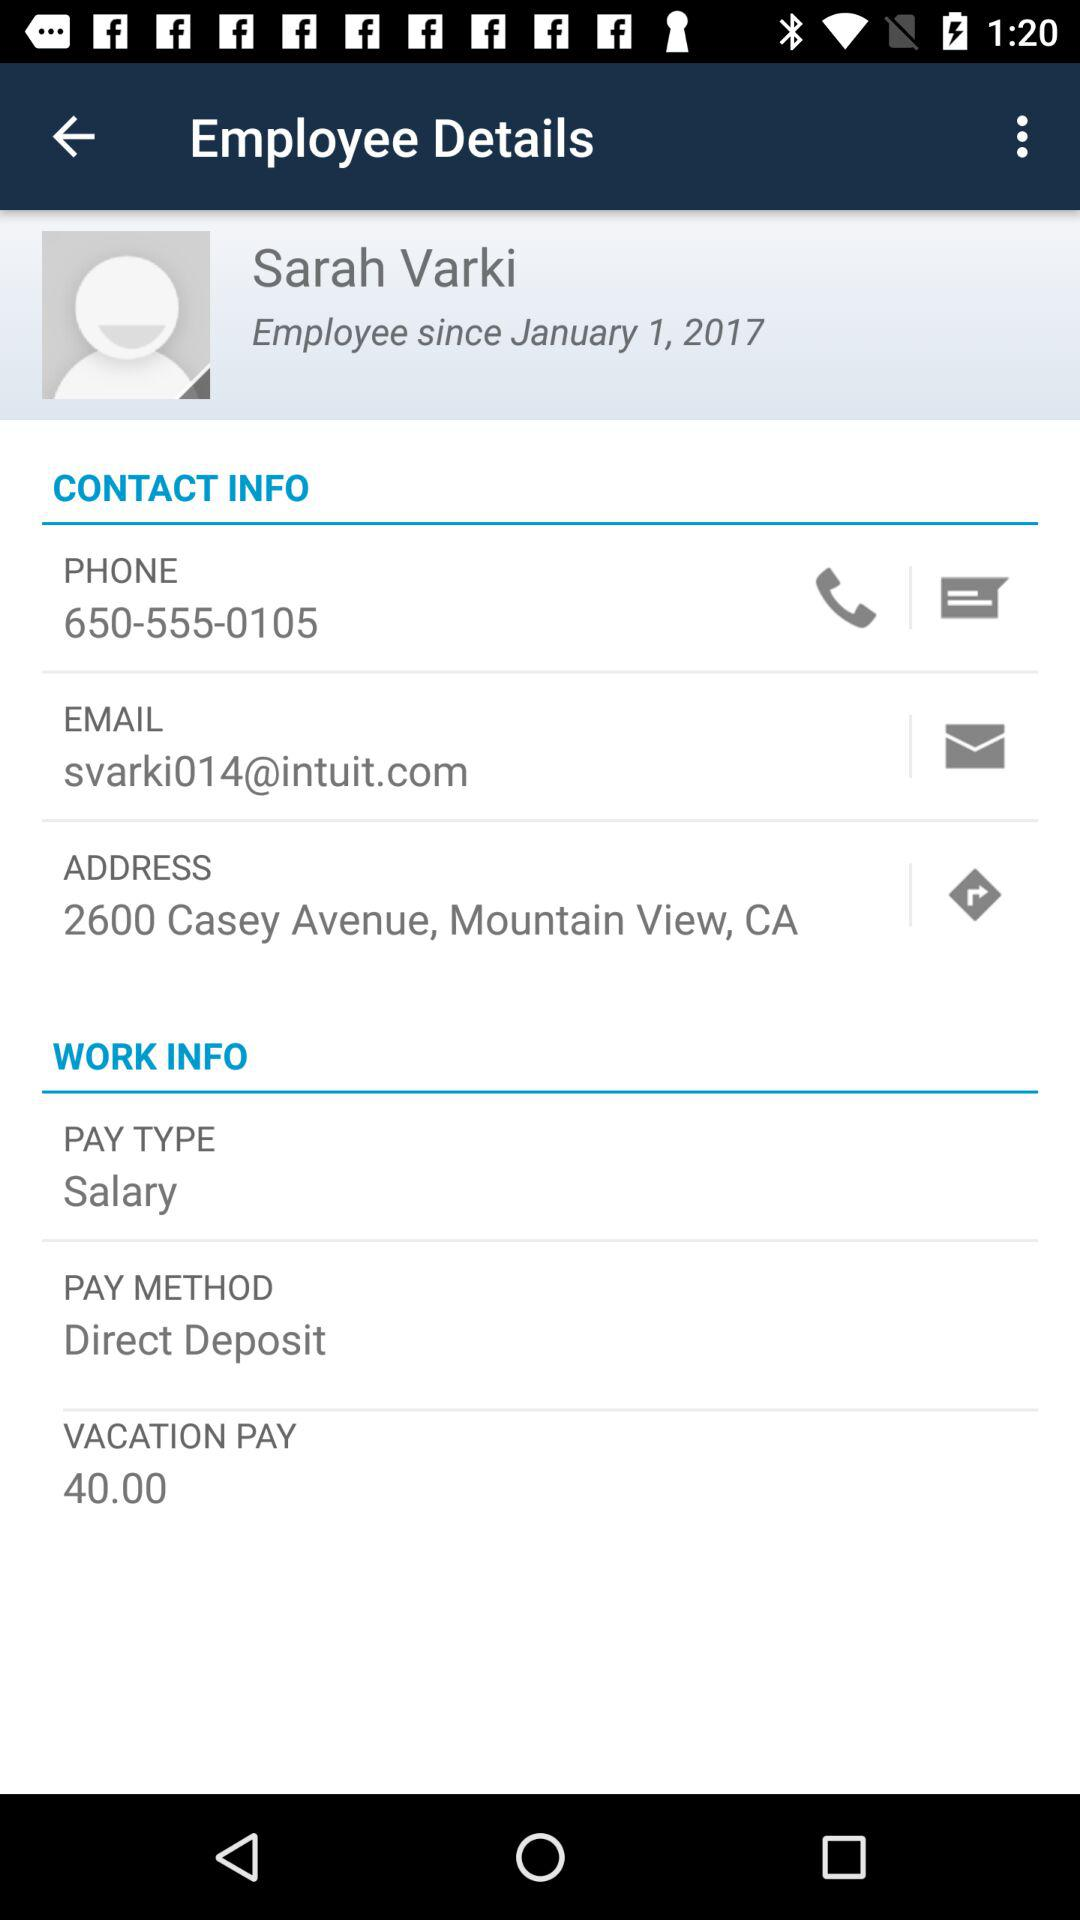What is the email ID of the employee? The email ID of the employee is svarki014@intuit.com. 